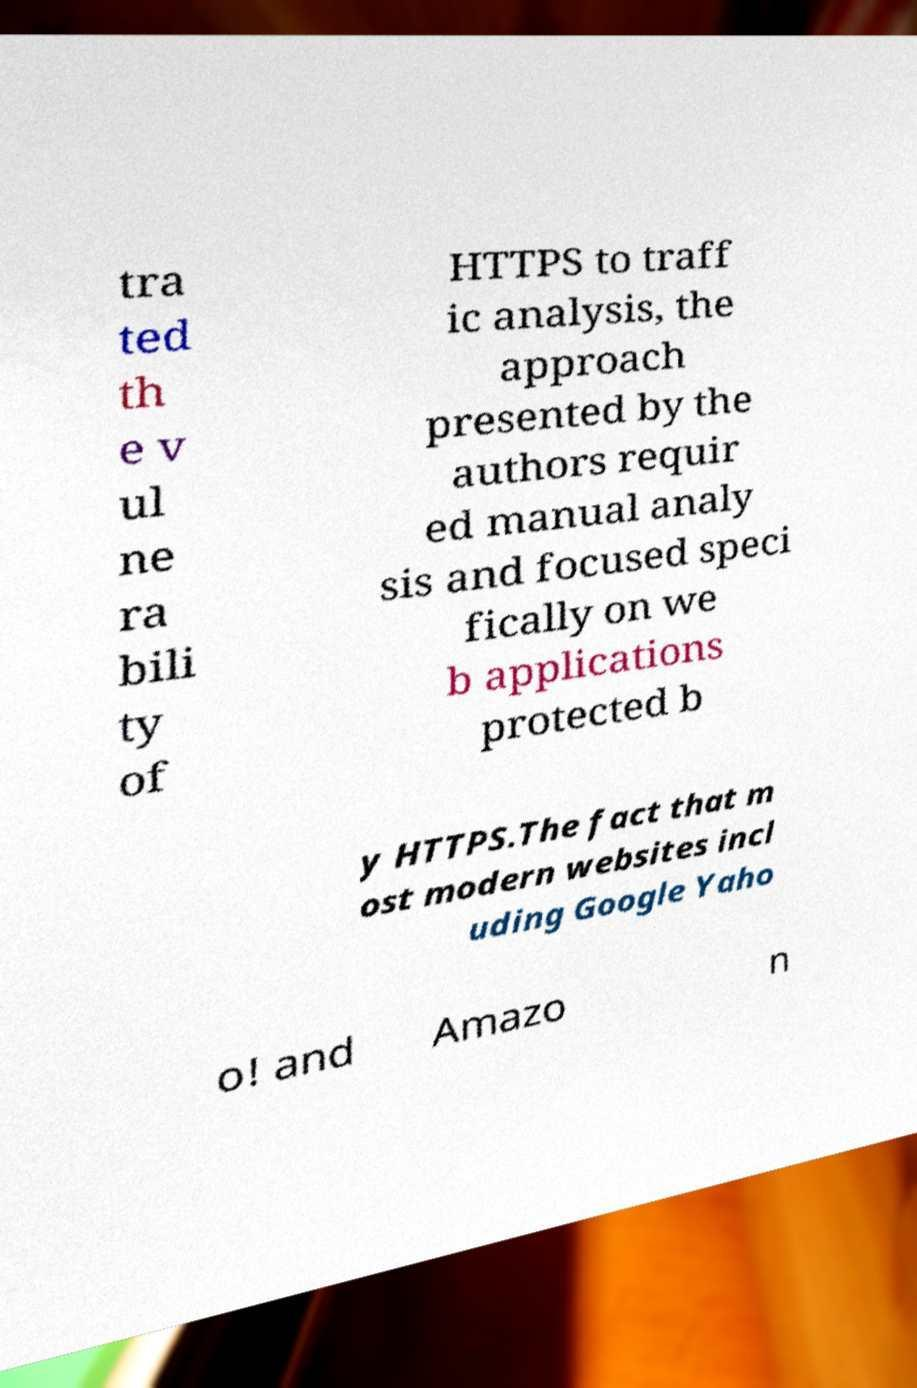There's text embedded in this image that I need extracted. Can you transcribe it verbatim? tra ted th e v ul ne ra bili ty of HTTPS to traff ic analysis, the approach presented by the authors requir ed manual analy sis and focused speci fically on we b applications protected b y HTTPS.The fact that m ost modern websites incl uding Google Yaho o! and Amazo n 